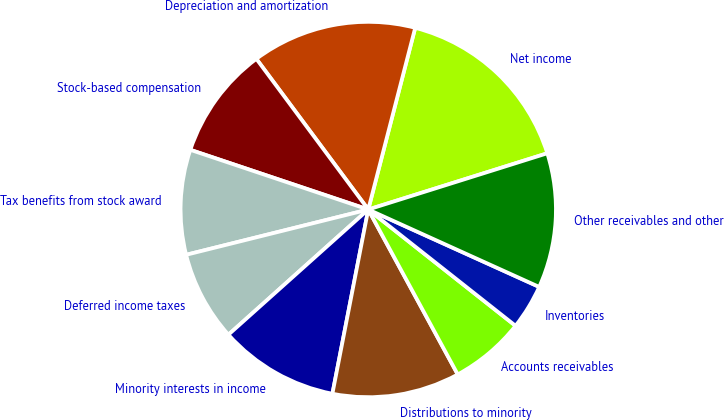<chart> <loc_0><loc_0><loc_500><loc_500><pie_chart><fcel>Net income<fcel>Depreciation and amortization<fcel>Stock-based compensation<fcel>Tax benefits from stock award<fcel>Deferred income taxes<fcel>Minority interests in income<fcel>Distributions to minority<fcel>Accounts receivables<fcel>Inventories<fcel>Other receivables and other<nl><fcel>16.13%<fcel>14.19%<fcel>9.68%<fcel>9.03%<fcel>7.74%<fcel>10.32%<fcel>10.97%<fcel>6.45%<fcel>3.87%<fcel>11.61%<nl></chart> 